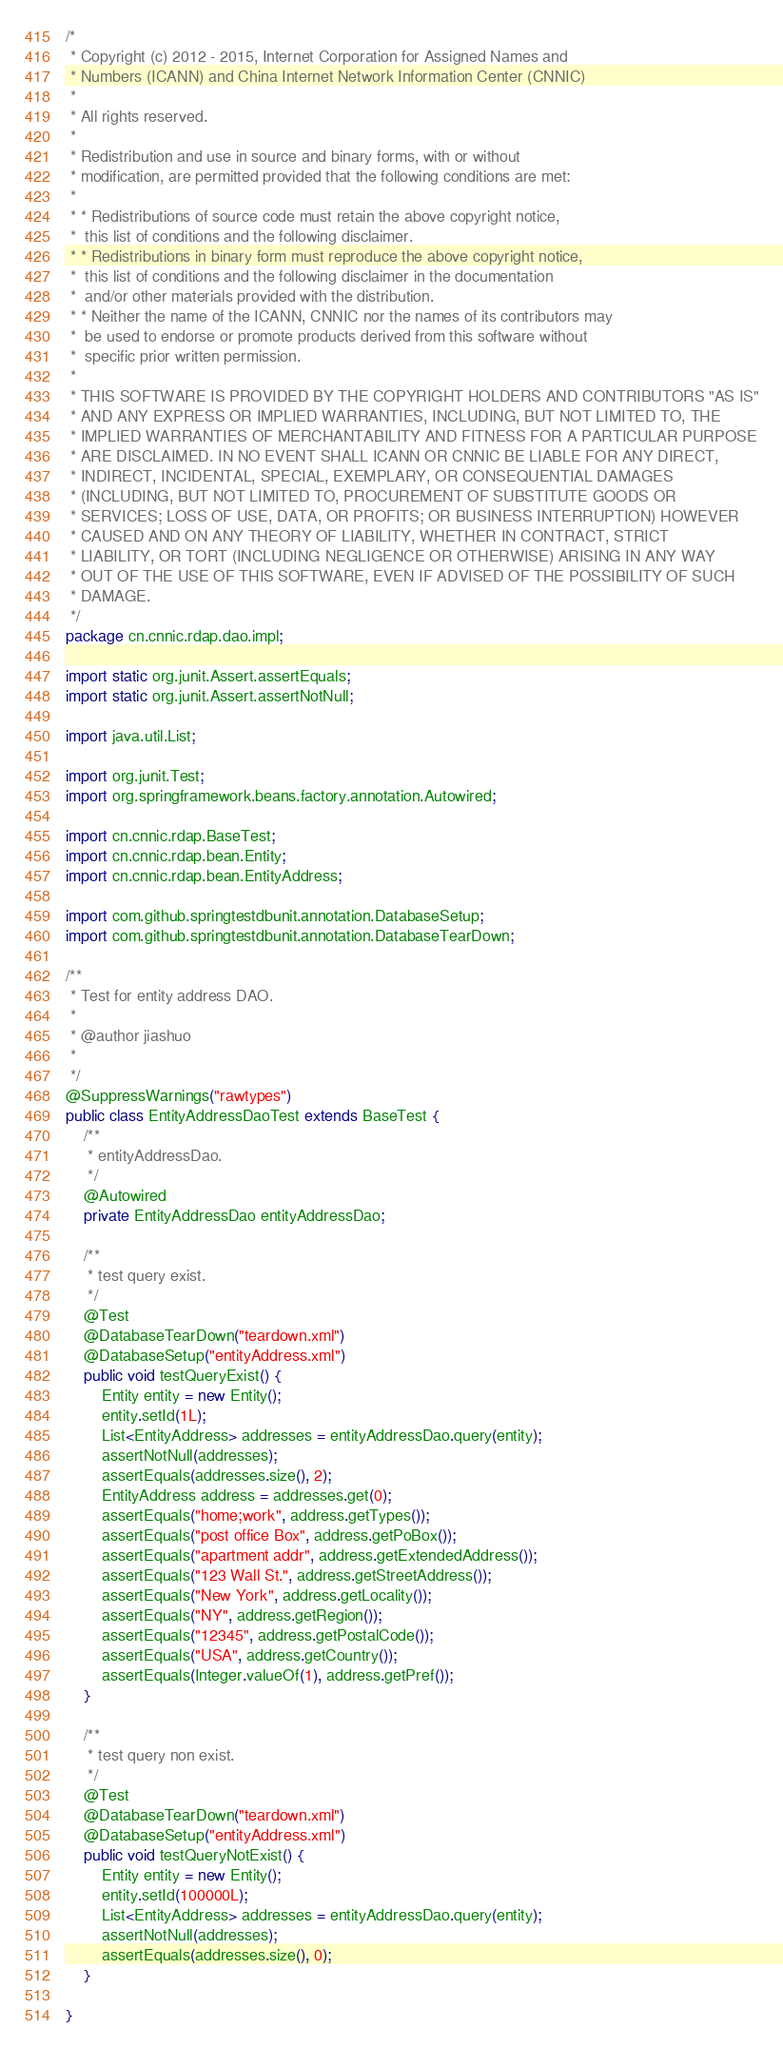Convert code to text. <code><loc_0><loc_0><loc_500><loc_500><_Java_>/*
 * Copyright (c) 2012 - 2015, Internet Corporation for Assigned Names and
 * Numbers (ICANN) and China Internet Network Information Center (CNNIC)
 *
 * All rights reserved.
 *
 * Redistribution and use in source and binary forms, with or without
 * modification, are permitted provided that the following conditions are met:
 *
 * * Redistributions of source code must retain the above copyright notice,
 *  this list of conditions and the following disclaimer.
 * * Redistributions in binary form must reproduce the above copyright notice,
 *  this list of conditions and the following disclaimer in the documentation
 *  and/or other materials provided with the distribution.
 * * Neither the name of the ICANN, CNNIC nor the names of its contributors may
 *  be used to endorse or promote products derived from this software without
 *  specific prior written permission.
 *
 * THIS SOFTWARE IS PROVIDED BY THE COPYRIGHT HOLDERS AND CONTRIBUTORS "AS IS"
 * AND ANY EXPRESS OR IMPLIED WARRANTIES, INCLUDING, BUT NOT LIMITED TO, THE
 * IMPLIED WARRANTIES OF MERCHANTABILITY AND FITNESS FOR A PARTICULAR PURPOSE
 * ARE DISCLAIMED. IN NO EVENT SHALL ICANN OR CNNIC BE LIABLE FOR ANY DIRECT,
 * INDIRECT, INCIDENTAL, SPECIAL, EXEMPLARY, OR CONSEQUENTIAL DAMAGES
 * (INCLUDING, BUT NOT LIMITED TO, PROCUREMENT OF SUBSTITUTE GOODS OR
 * SERVICES; LOSS OF USE, DATA, OR PROFITS; OR BUSINESS INTERRUPTION) HOWEVER
 * CAUSED AND ON ANY THEORY OF LIABILITY, WHETHER IN CONTRACT, STRICT
 * LIABILITY, OR TORT (INCLUDING NEGLIGENCE OR OTHERWISE) ARISING IN ANY WAY
 * OUT OF THE USE OF THIS SOFTWARE, EVEN IF ADVISED OF THE POSSIBILITY OF SUCH
 * DAMAGE.
 */
package cn.cnnic.rdap.dao.impl;

import static org.junit.Assert.assertEquals;
import static org.junit.Assert.assertNotNull;

import java.util.List;

import org.junit.Test;
import org.springframework.beans.factory.annotation.Autowired;

import cn.cnnic.rdap.BaseTest;
import cn.cnnic.rdap.bean.Entity;
import cn.cnnic.rdap.bean.EntityAddress;

import com.github.springtestdbunit.annotation.DatabaseSetup;
import com.github.springtestdbunit.annotation.DatabaseTearDown;

/**
 * Test for entity address DAO.
 *
 * @author jiashuo
 *
 */
@SuppressWarnings("rawtypes")
public class EntityAddressDaoTest extends BaseTest {
    /**
     * entityAddressDao.
     */
    @Autowired
    private EntityAddressDao entityAddressDao;

    /**
     * test query exist.
     */
    @Test
    @DatabaseTearDown("teardown.xml")
    @DatabaseSetup("entityAddress.xml")
    public void testQueryExist() {
        Entity entity = new Entity();
        entity.setId(1L);
        List<EntityAddress> addresses = entityAddressDao.query(entity);
        assertNotNull(addresses);
        assertEquals(addresses.size(), 2);
        EntityAddress address = addresses.get(0);
        assertEquals("home;work", address.getTypes());
        assertEquals("post office Box", address.getPoBox());
        assertEquals("apartment addr", address.getExtendedAddress());
        assertEquals("123 Wall St.", address.getStreetAddress());
        assertEquals("New York", address.getLocality());
        assertEquals("NY", address.getRegion());
        assertEquals("12345", address.getPostalCode());
        assertEquals("USA", address.getCountry());
        assertEquals(Integer.valueOf(1), address.getPref());
    }

    /**
     * test query non exist.
     */
    @Test
    @DatabaseTearDown("teardown.xml")
    @DatabaseSetup("entityAddress.xml")
    public void testQueryNotExist() {
        Entity entity = new Entity();
        entity.setId(100000L);
        List<EntityAddress> addresses = entityAddressDao.query(entity);
        assertNotNull(addresses);
        assertEquals(addresses.size(), 0);
    }

}
</code> 